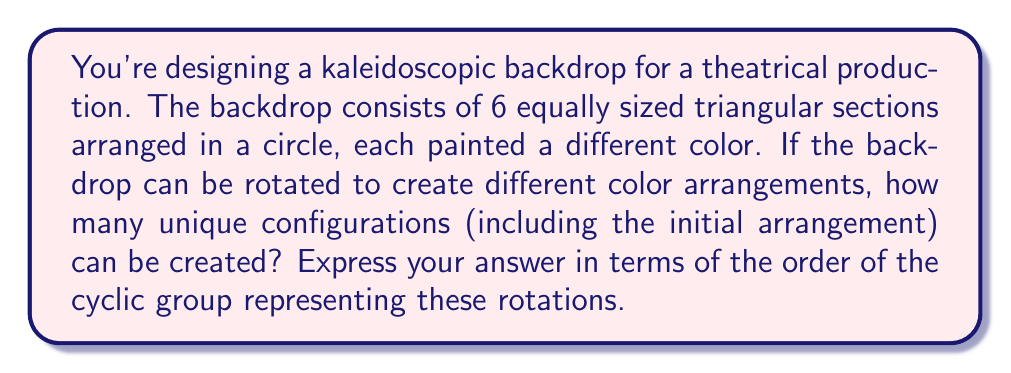Can you solve this math problem? Let's approach this step-by-step:

1) First, we need to understand what the question is asking. We have a circular backdrop divided into 6 equal sections, each with a different color. We're looking for the number of unique arrangements that can be created by rotating this backdrop.

2) This scenario can be modeled using a cyclic group. The group operation here is rotation, and each element of the group represents a distinct rotation of the backdrop.

3) In group theory, the order of a group is the number of elements in the group. In this case, it's the number of unique arrangements we can create through rotations.

4) To find the order, we need to consider how many rotations will bring us back to the original configuration. Since there are 6 sections, a rotation of 360°/6 = 60° will move each color to the next position.

5) The possible rotations are:
   - 0° (identity)
   - 60°
   - 120°
   - 180°
   - 240°
   - 300°

6) After a 360° rotation (or 6 steps of 60°), we return to the original configuration.

7) Therefore, the cyclic group representing these rotations has 6 elements, corresponding to the 6 unique configurations we can create.

8) In group theory notation, this group can be written as $C_6$ or $\mathbb{Z}/6\mathbb{Z}$.

9) The order of a cyclic group $C_n$ is always $n$.

Thus, the order of the cyclic group representing these color rotations is 6.
Answer: The order of the cyclic group is 6. 